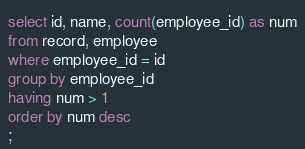Convert code to text. <code><loc_0><loc_0><loc_500><loc_500><_SQL_>select id, name, count(employee_id) as num
from record, employee
where employee_id = id
group by employee_id
having num > 1
order by num desc
;
</code> 